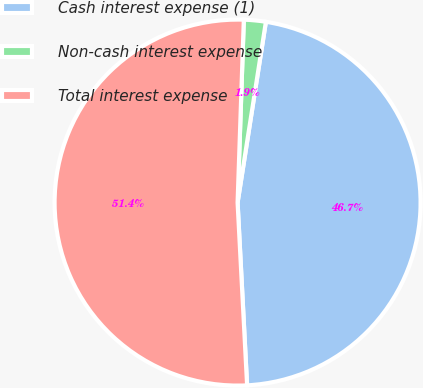<chart> <loc_0><loc_0><loc_500><loc_500><pie_chart><fcel>Cash interest expense (1)<fcel>Non-cash interest expense<fcel>Total interest expense<nl><fcel>46.7%<fcel>1.93%<fcel>51.37%<nl></chart> 